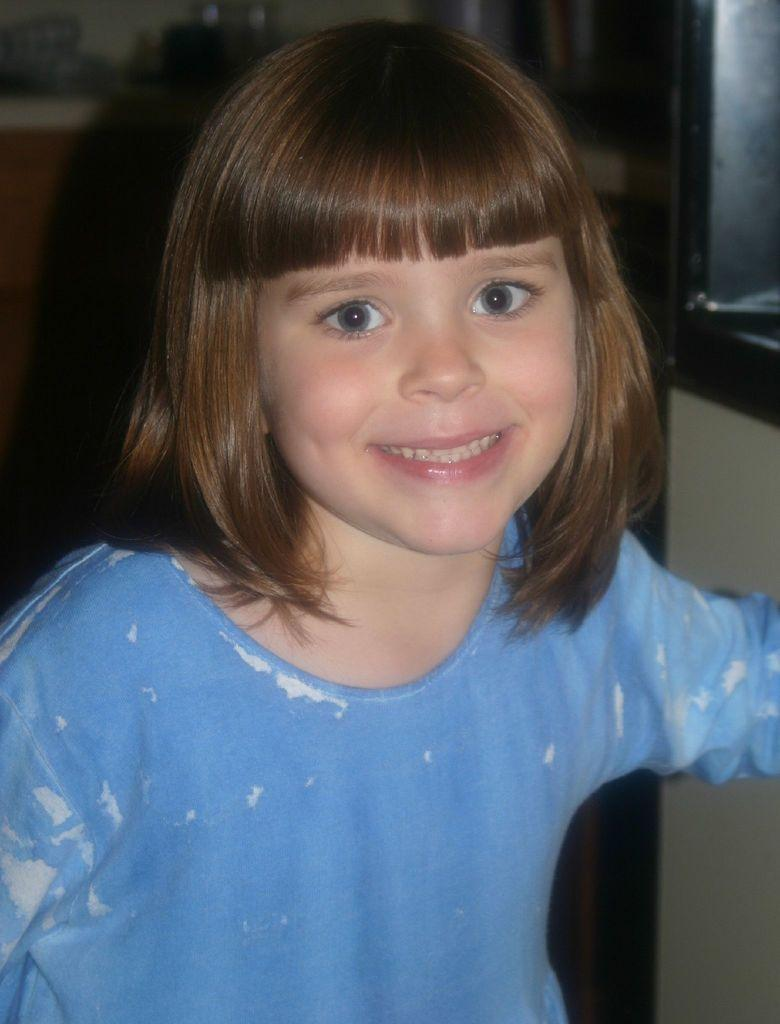Who is the main subject in the image? There is a girl in the image. What is the girl doing in the image? The girl is smiling. What can be seen in the background of the image? There are objects in the background of the image. What type of rings can be seen on the girl's temper in the image? There is no mention of rings or a temper in the image, and therefore no such objects can be observed. 